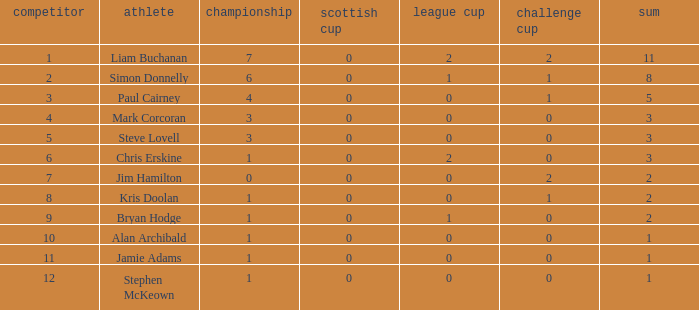What was the least amount of points recorded in the league cup? 0.0. Could you parse the entire table as a dict? {'header': ['competitor', 'athlete', 'championship', 'scottish cup', 'league cup', 'challenge cup', 'sum'], 'rows': [['1', 'Liam Buchanan', '7', '0', '2', '2', '11'], ['2', 'Simon Donnelly', '6', '0', '1', '1', '8'], ['3', 'Paul Cairney', '4', '0', '0', '1', '5'], ['4', 'Mark Corcoran', '3', '0', '0', '0', '3'], ['5', 'Steve Lovell', '3', '0', '0', '0', '3'], ['6', 'Chris Erskine', '1', '0', '2', '0', '3'], ['7', 'Jim Hamilton', '0', '0', '0', '2', '2'], ['8', 'Kris Doolan', '1', '0', '0', '1', '2'], ['9', 'Bryan Hodge', '1', '0', '1', '0', '2'], ['10', 'Alan Archibald', '1', '0', '0', '0', '1'], ['11', 'Jamie Adams', '1', '0', '0', '0', '1'], ['12', 'Stephen McKeown', '1', '0', '0', '0', '1']]} 